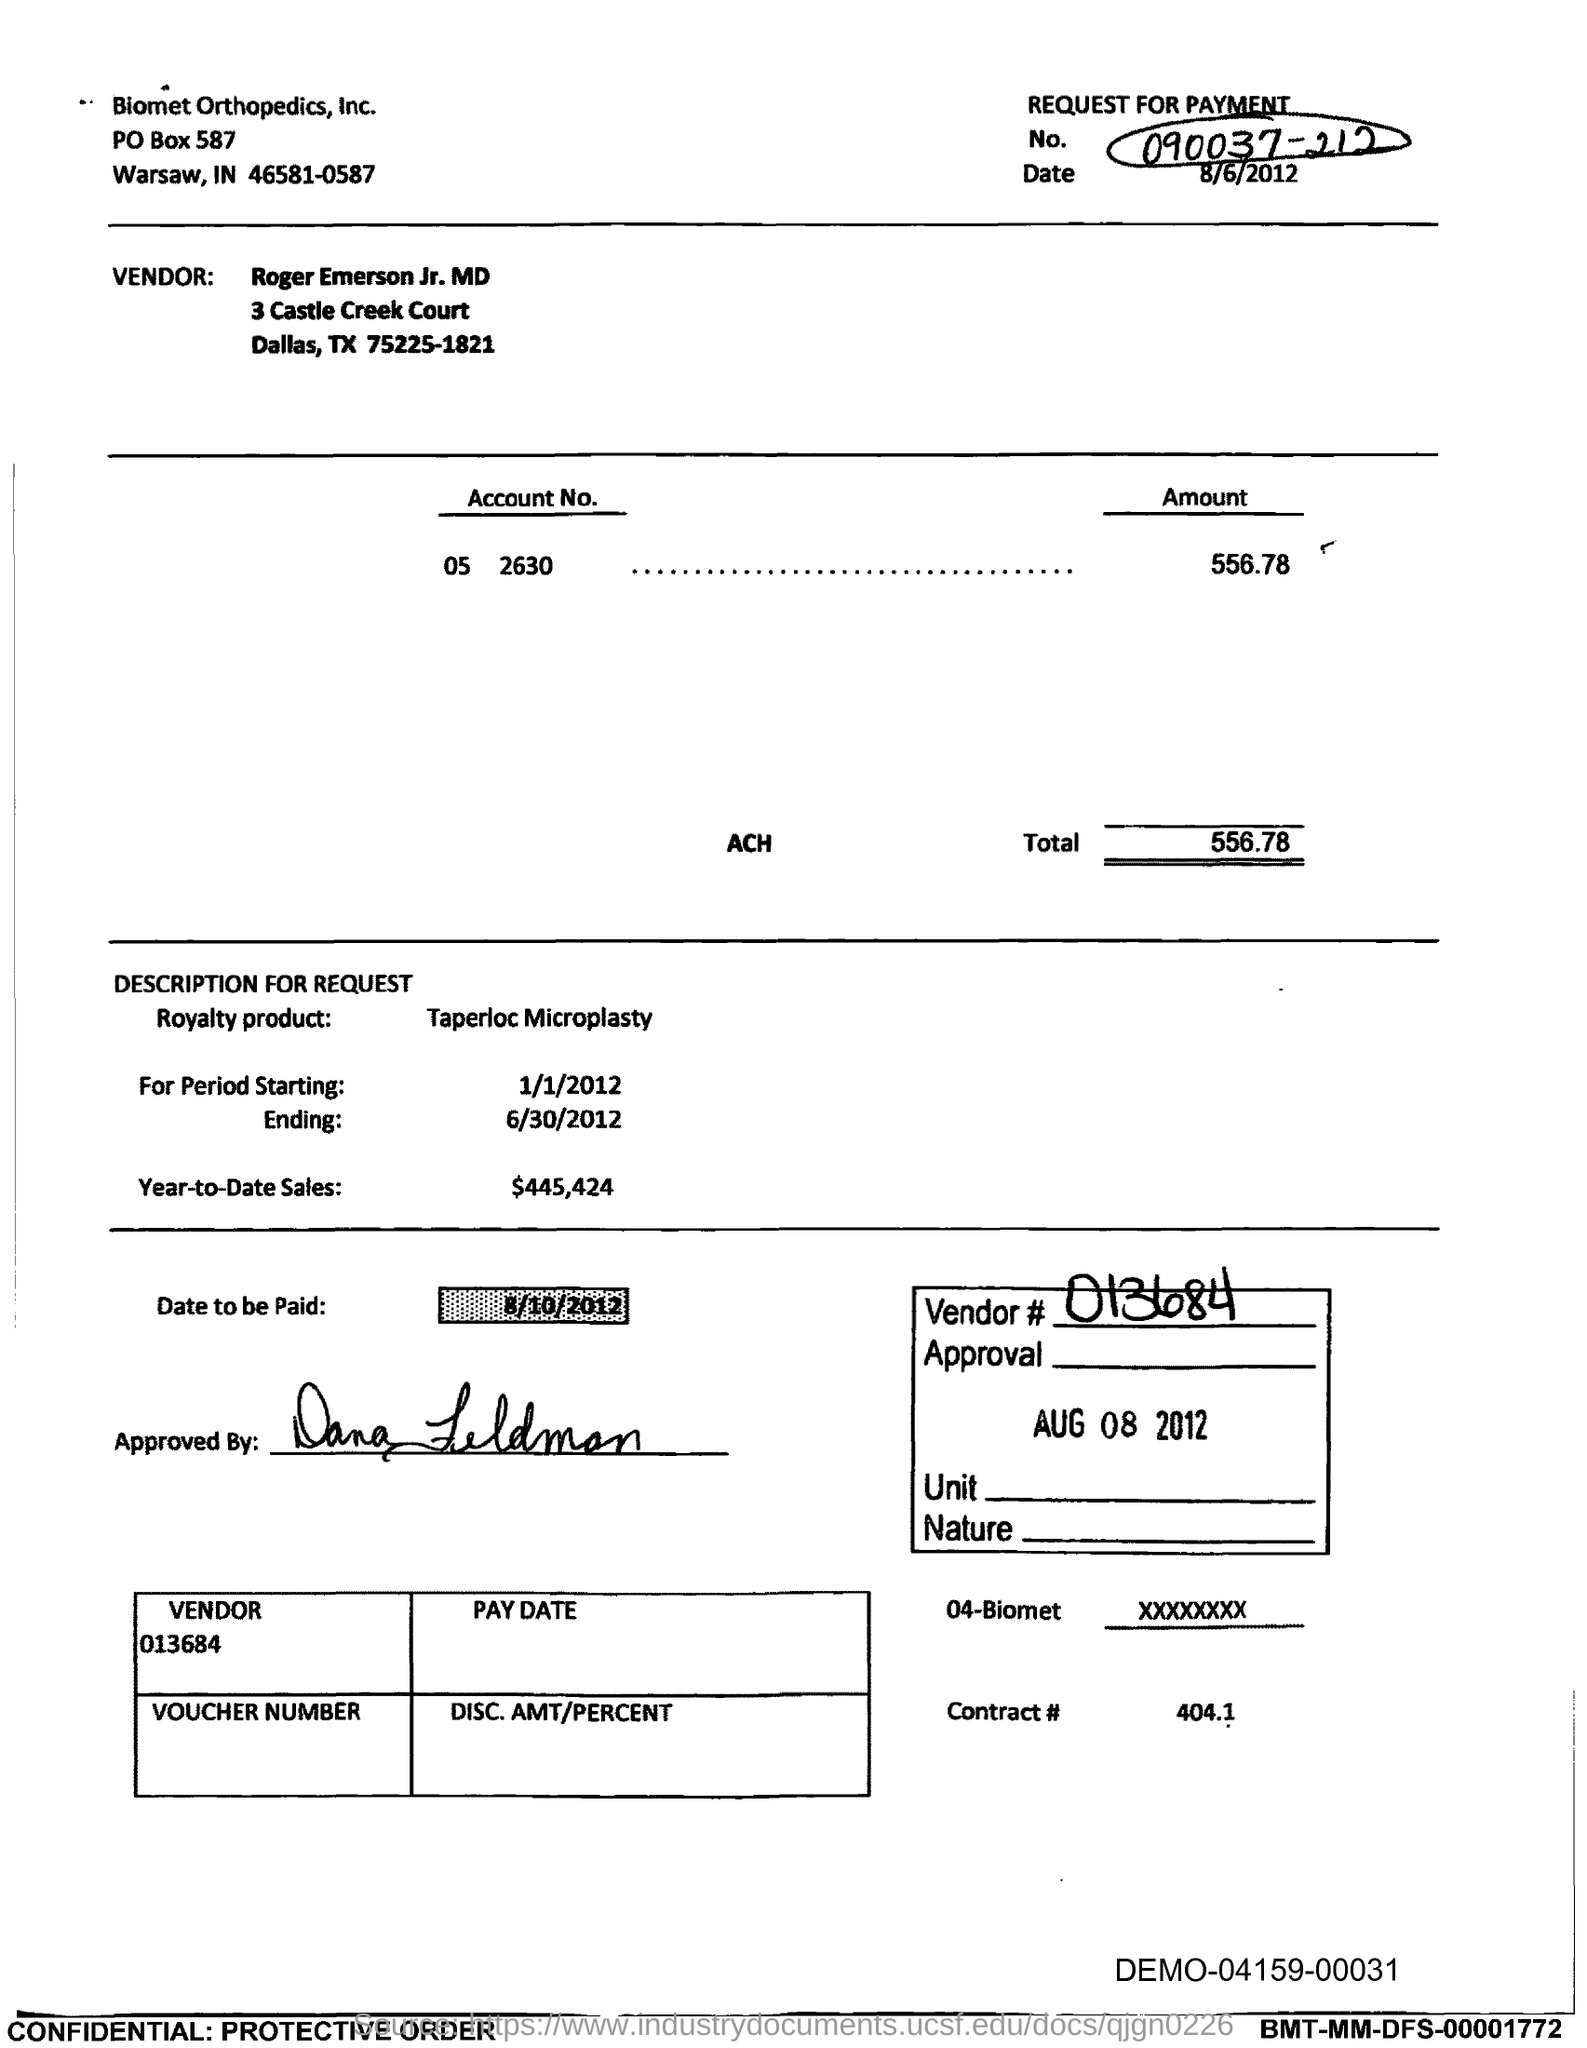Outline some significant characteristics in this image. The vendor number provided in the document is 013684. The vendor in the document is Roger Emerson Jr. MD. The start date of the royalty period is January 1, 2012. The year-to-date sales of the royalty product are $445,424. The Account No. mentioned in the document is 05 2630. 